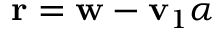<formula> <loc_0><loc_0><loc_500><loc_500>r = w - v _ { 1 } \alpha</formula> 